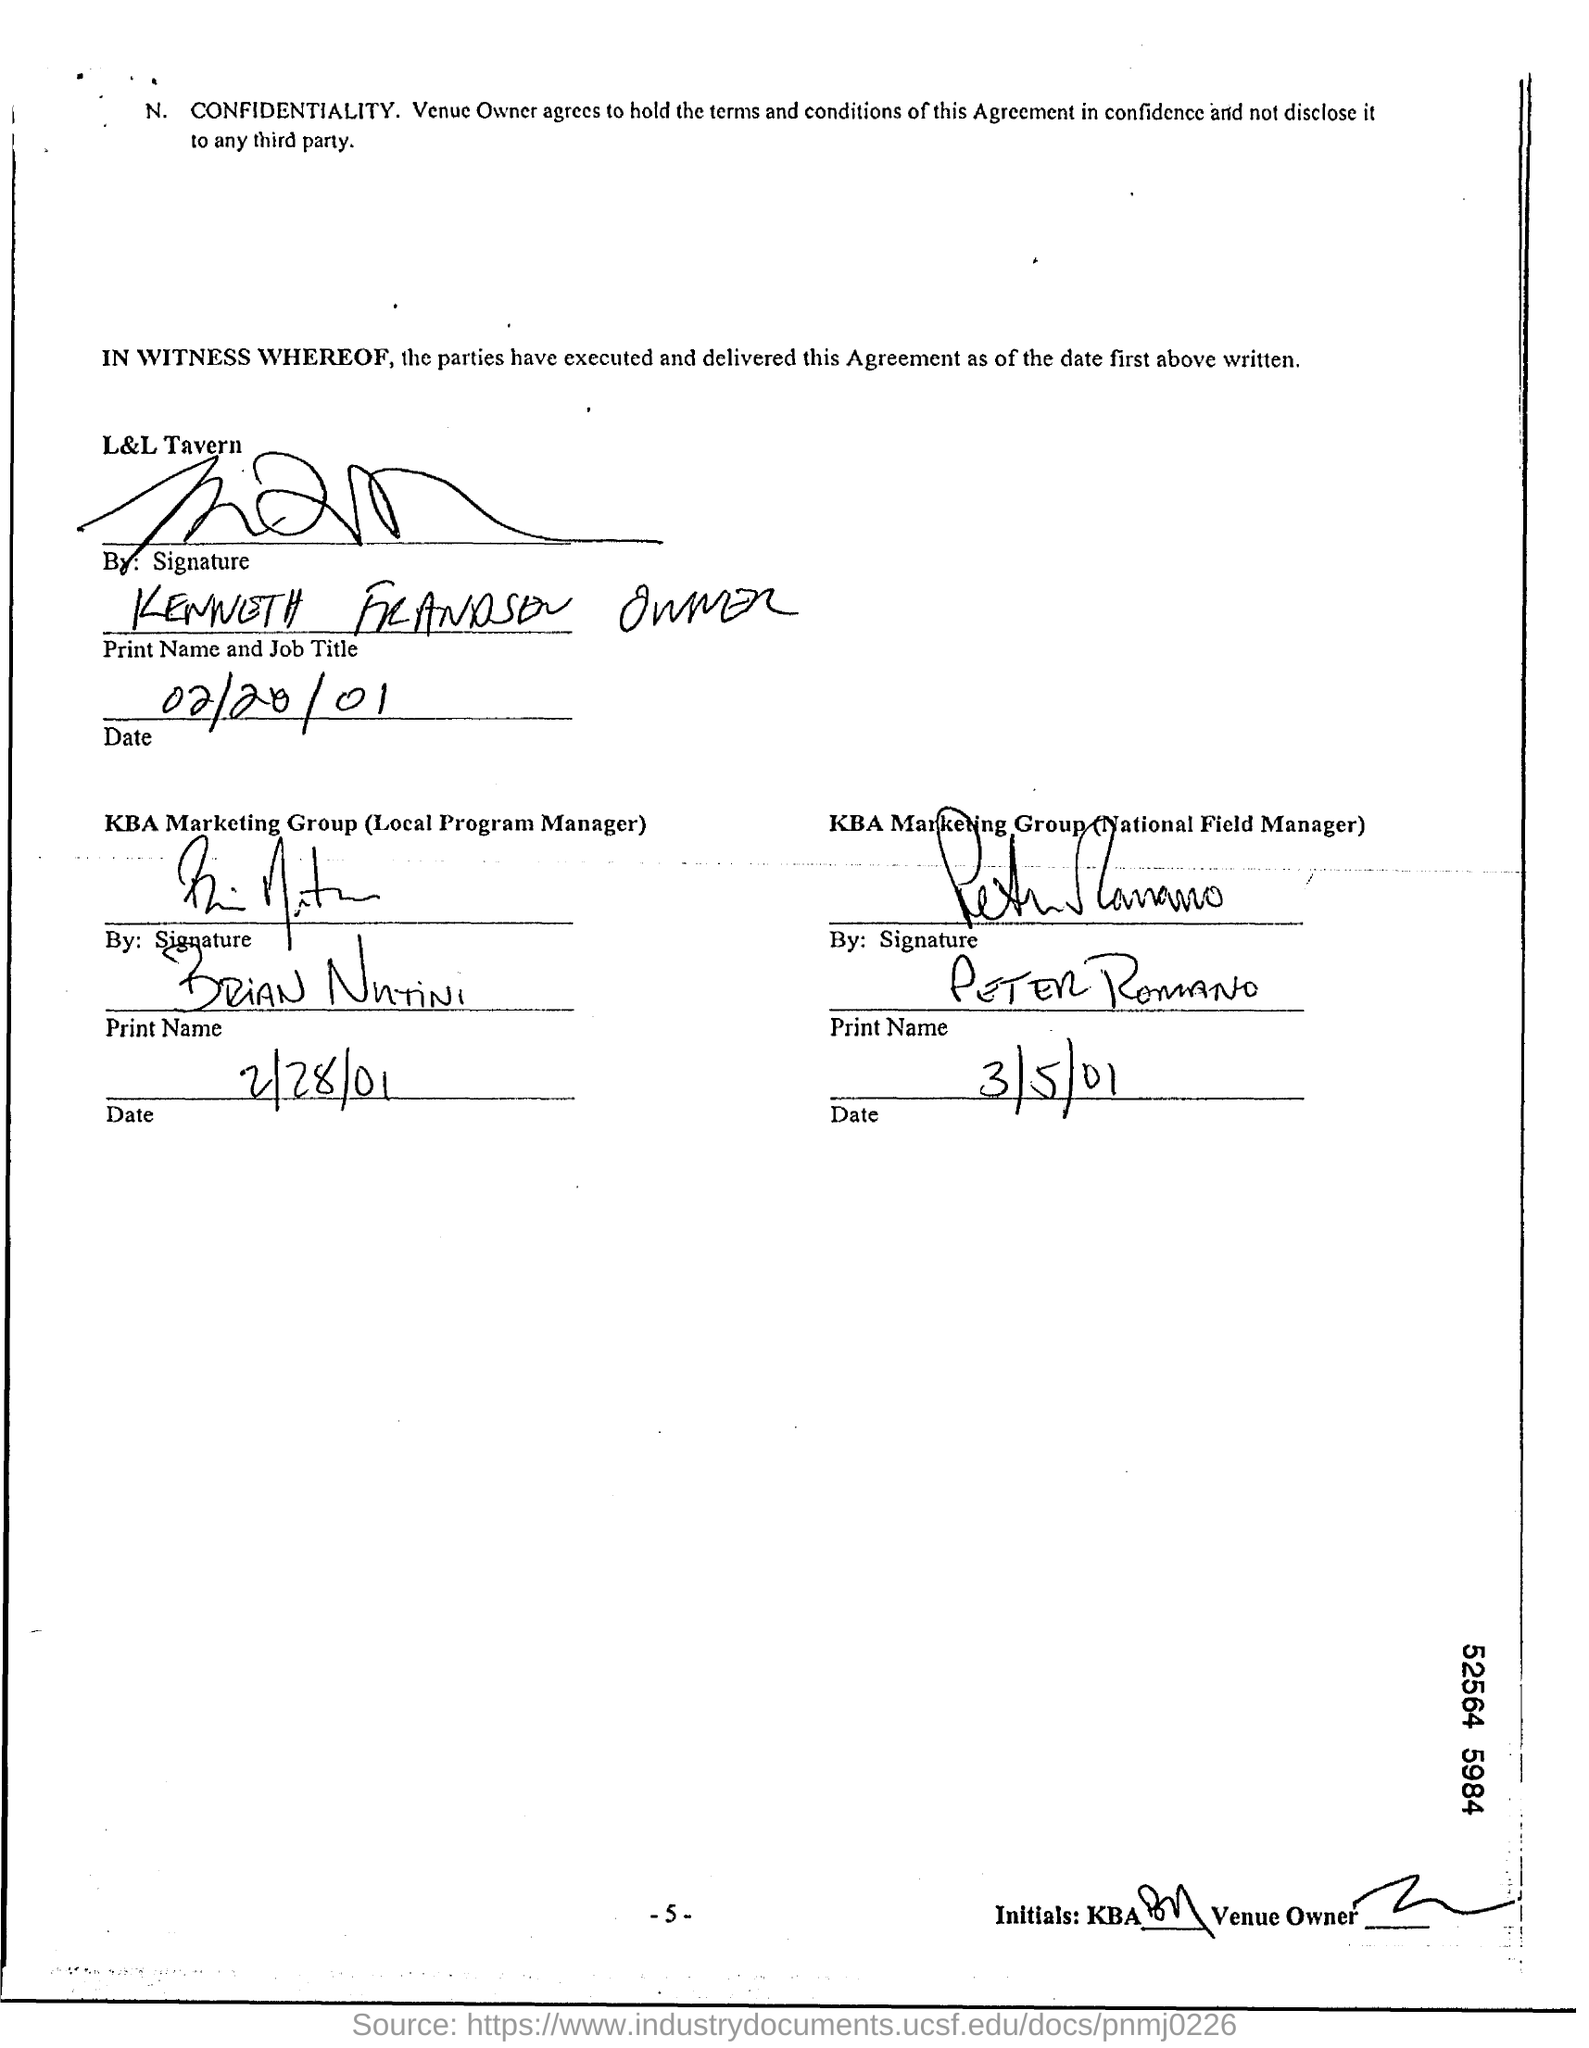Can you tell me who signed the document for KBA Marketing Group as the Local Program Manager? The signature for the Local Program Manager from KBA Marketing Group is not entirely clear, but it appears to be signed by an individual whose first name starts with an 'R' and the last name might start with an 'N'. Is there a date next to this signature? Yes, there is a date next to the signature. It reads '4/28/01'. 